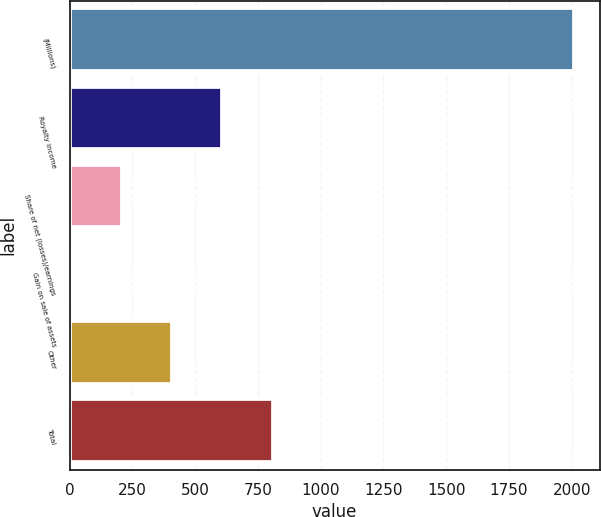<chart> <loc_0><loc_0><loc_500><loc_500><bar_chart><fcel>(Millions)<fcel>Royalty income<fcel>Share of net (losses)/earnings<fcel>Gain on sale of assets<fcel>Other<fcel>Total<nl><fcel>2011<fcel>608.2<fcel>207.4<fcel>7<fcel>407.8<fcel>808.6<nl></chart> 